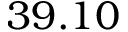Convert formula to latex. <formula><loc_0><loc_0><loc_500><loc_500>3 9 . 1 0</formula> 